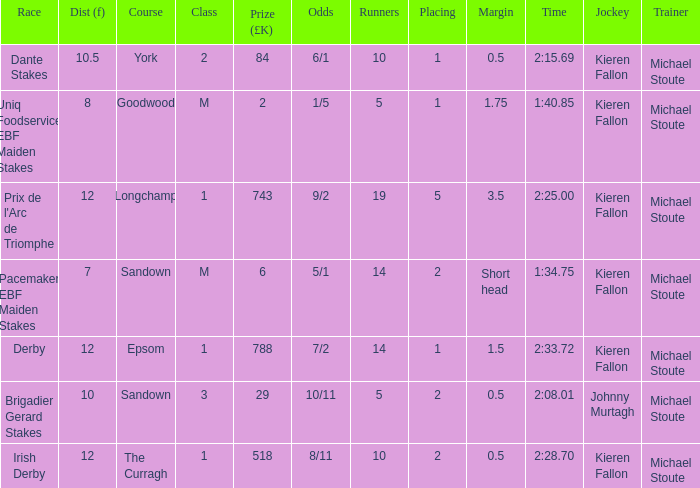Name the least runners with dist of 10.5 10.0. 